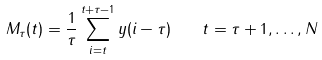Convert formula to latex. <formula><loc_0><loc_0><loc_500><loc_500>M _ { \tau } ( t ) = \frac { 1 } { \tau } \sum _ { i = t } ^ { t + \tau - 1 } y ( i - \tau ) \quad t = \tau + 1 , \dots , N</formula> 